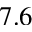Convert formula to latex. <formula><loc_0><loc_0><loc_500><loc_500>7 . 6</formula> 